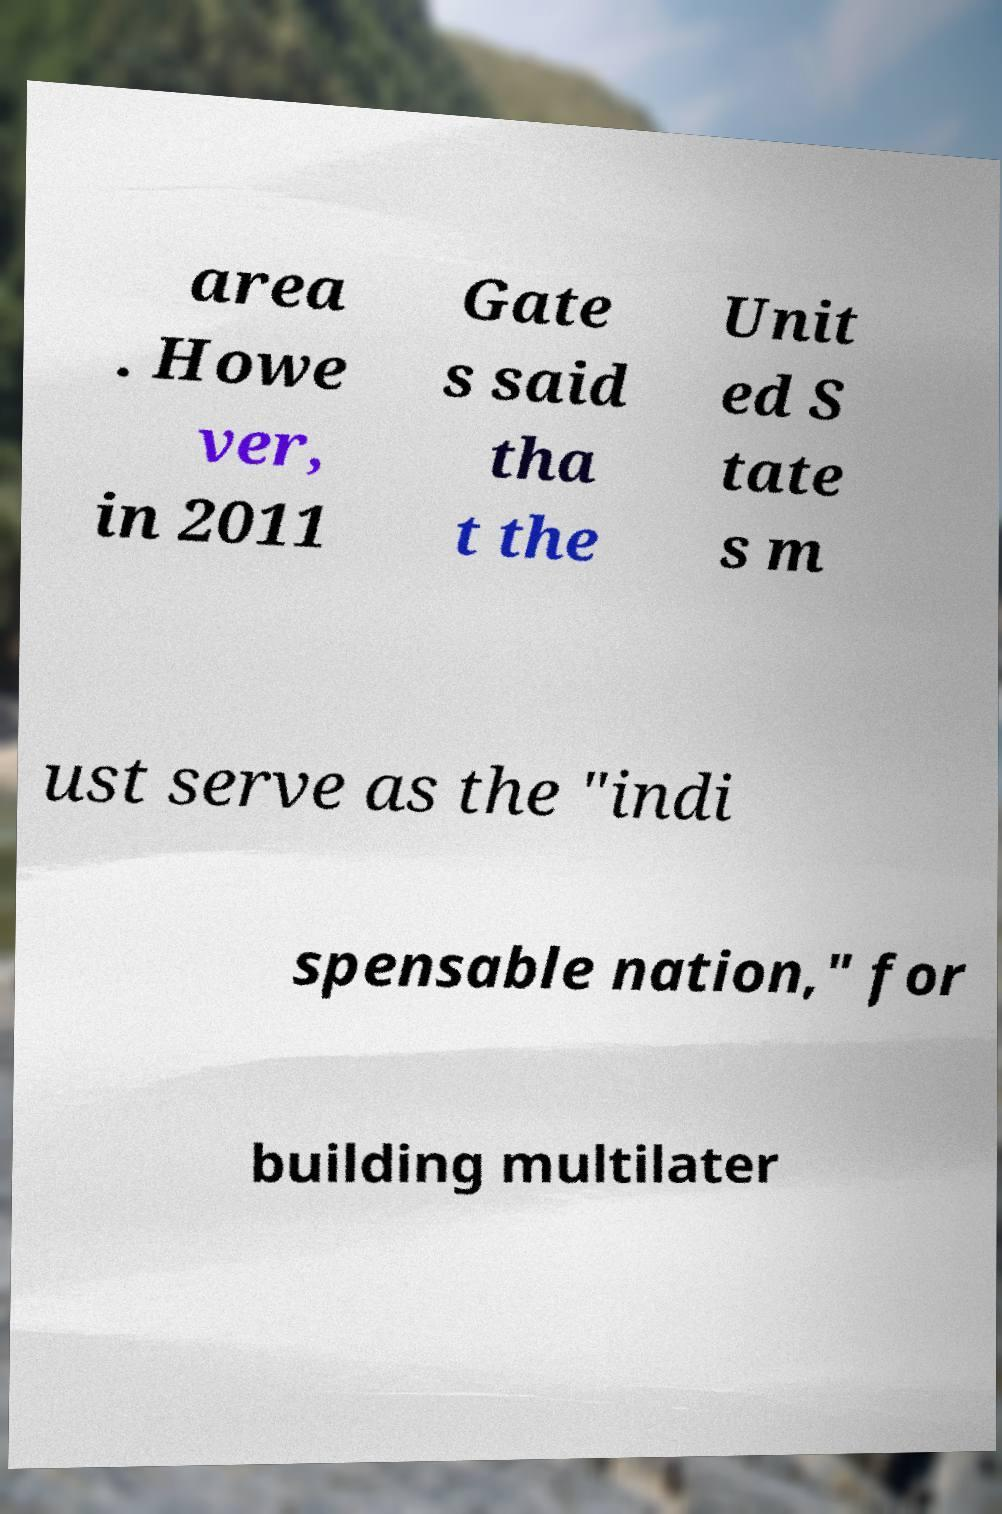Can you read and provide the text displayed in the image?This photo seems to have some interesting text. Can you extract and type it out for me? area . Howe ver, in 2011 Gate s said tha t the Unit ed S tate s m ust serve as the "indi spensable nation," for building multilater 